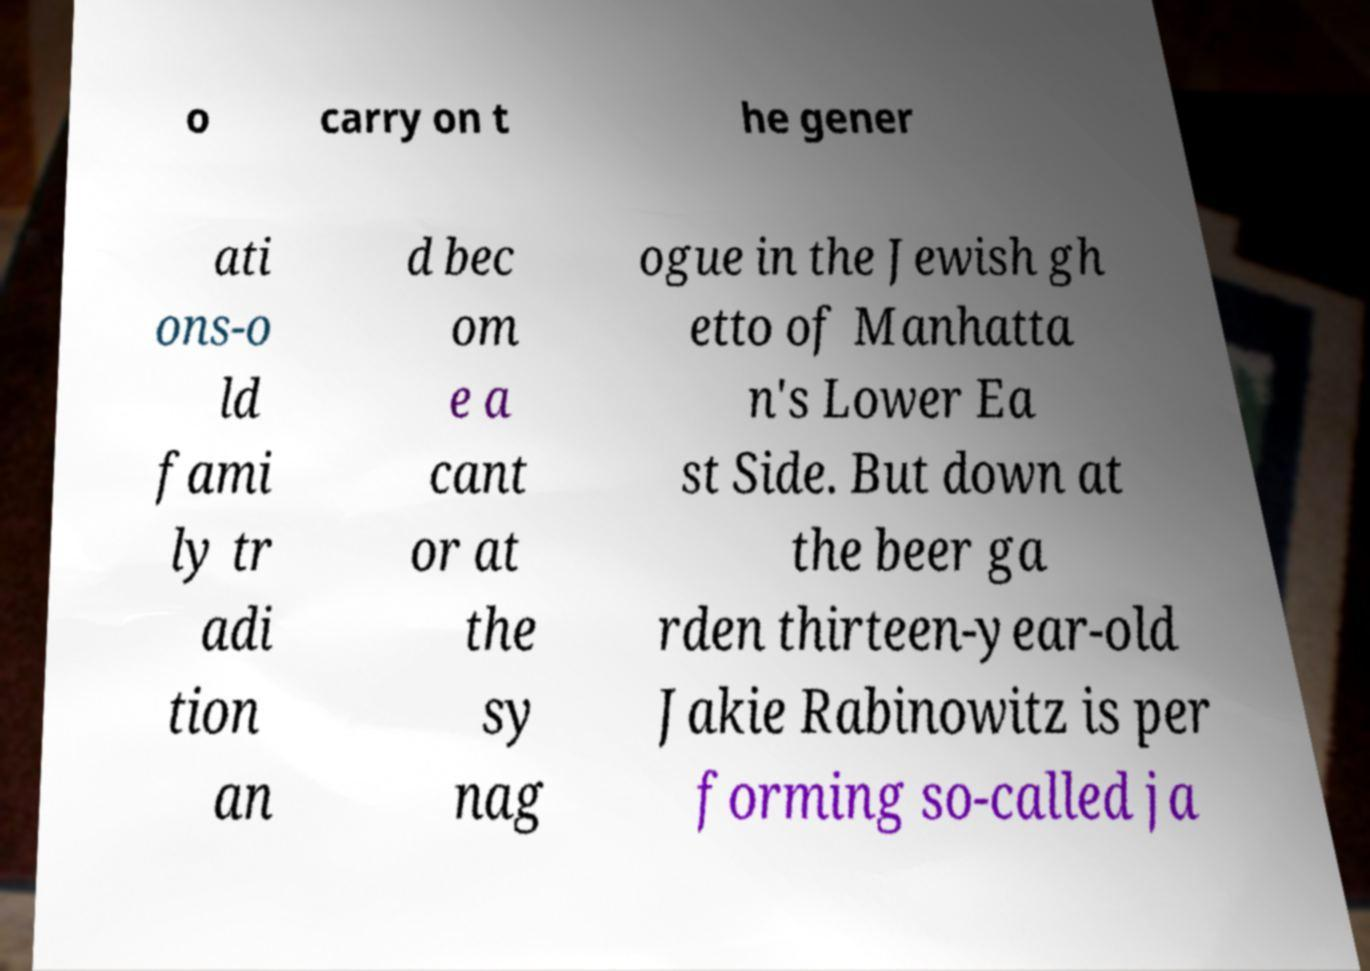I need the written content from this picture converted into text. Can you do that? o carry on t he gener ati ons-o ld fami ly tr adi tion an d bec om e a cant or at the sy nag ogue in the Jewish gh etto of Manhatta n's Lower Ea st Side. But down at the beer ga rden thirteen-year-old Jakie Rabinowitz is per forming so-called ja 